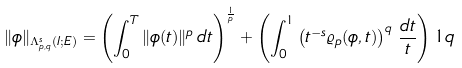Convert formula to latex. <formula><loc_0><loc_0><loc_500><loc_500>\| \phi \| _ { \Lambda ^ { s } _ { p , q } ( I ; E ) } = \left ( \int _ { 0 } ^ { T } \| \phi ( t ) \| ^ { p } \, d t \right ) ^ { \frac { 1 } { p } } + \left ( \int _ { 0 } ^ { 1 } \left ( t ^ { - s } \varrho _ { p } ( \phi , t ) \right ) ^ { q } \, \frac { d t } { t } \right ) ^ { } { 1 } q</formula> 